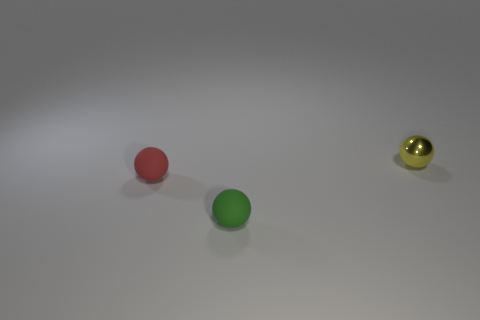Subtract all tiny yellow spheres. How many spheres are left? 2 Add 3 gray matte cylinders. How many objects exist? 6 Subtract all red spheres. How many spheres are left? 2 Subtract 0 cyan blocks. How many objects are left? 3 Subtract 1 spheres. How many spheres are left? 2 Subtract all red spheres. Subtract all blue cylinders. How many spheres are left? 2 Subtract all yellow cubes. How many green balls are left? 1 Subtract all tiny gray rubber cylinders. Subtract all small yellow spheres. How many objects are left? 2 Add 3 tiny shiny balls. How many tiny shiny balls are left? 4 Add 2 small green rubber objects. How many small green rubber objects exist? 3 